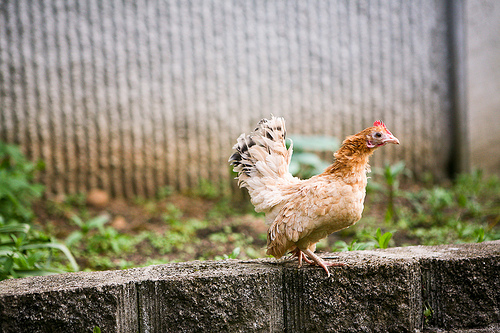<image>
Is there a rooster to the left of the plants? No. The rooster is not to the left of the plants. From this viewpoint, they have a different horizontal relationship. 